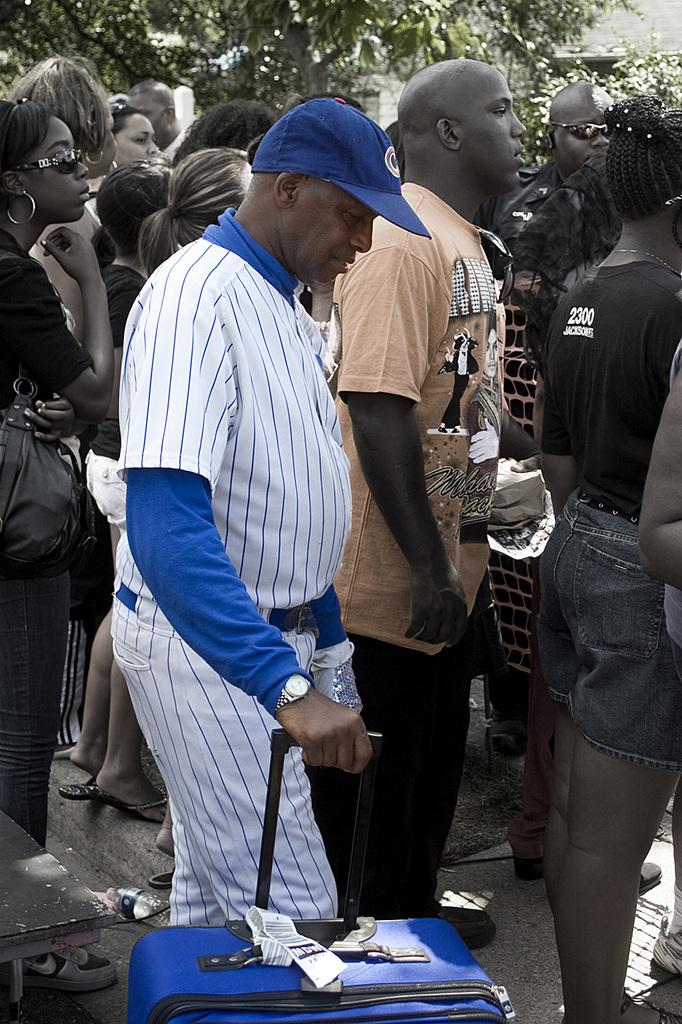How many people are in the image? There are multiple people in the image. What are the people in the image doing? The people are standing in a group. Can you describe any specific items that one of the people is holding? One person is holding a luggage bag. What can be seen in the background of the image? There are trees and buildings visible in the background. What type of quilt is being displayed on the wall in the image? There is no quilt present in the image; it features a group of people standing together. 